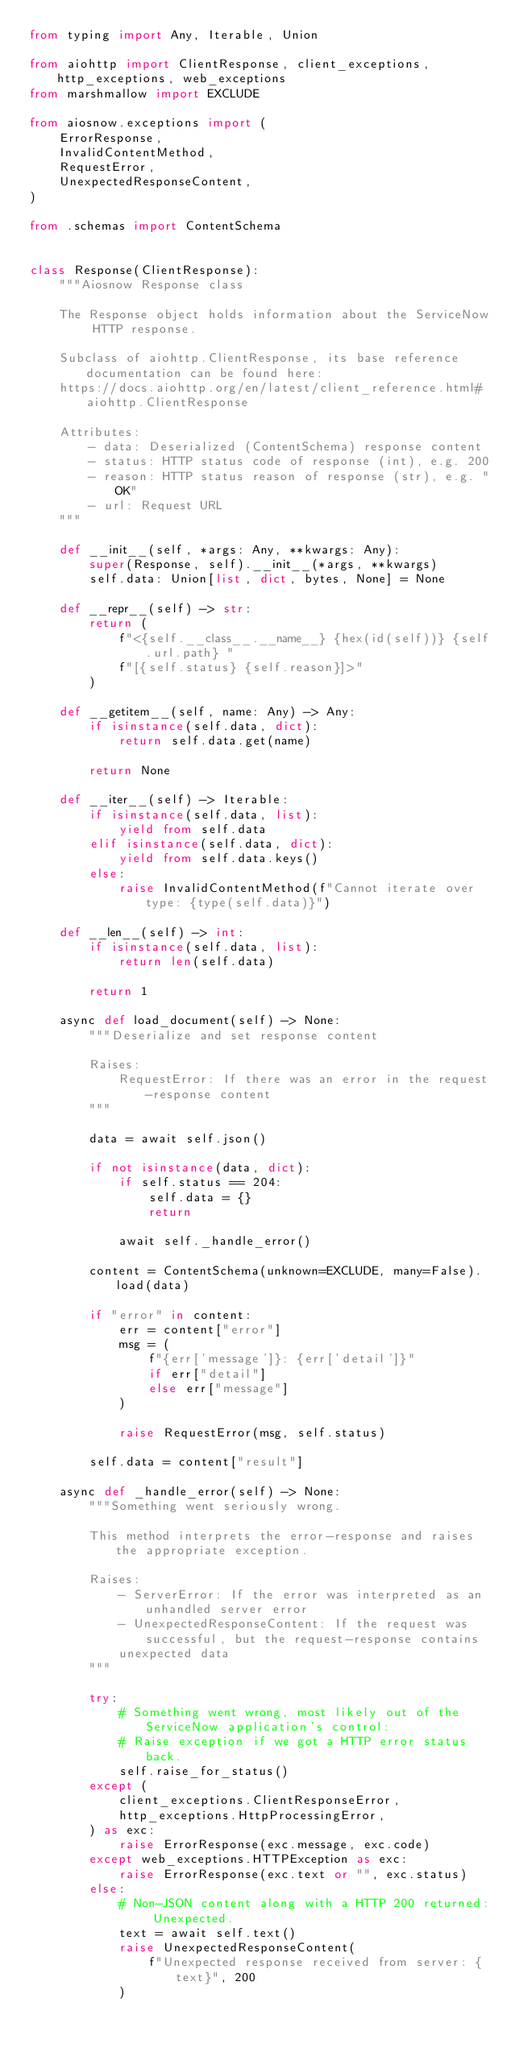<code> <loc_0><loc_0><loc_500><loc_500><_Python_>from typing import Any, Iterable, Union

from aiohttp import ClientResponse, client_exceptions, http_exceptions, web_exceptions
from marshmallow import EXCLUDE

from aiosnow.exceptions import (
    ErrorResponse,
    InvalidContentMethod,
    RequestError,
    UnexpectedResponseContent,
)

from .schemas import ContentSchema


class Response(ClientResponse):
    """Aiosnow Response class

    The Response object holds information about the ServiceNow HTTP response.

    Subclass of aiohttp.ClientResponse, its base reference documentation can be found here:
    https://docs.aiohttp.org/en/latest/client_reference.html#aiohttp.ClientResponse

    Attributes:
        - data: Deserialized (ContentSchema) response content
        - status: HTTP status code of response (int), e.g. 200
        - reason: HTTP status reason of response (str), e.g. "OK"
        - url: Request URL
    """

    def __init__(self, *args: Any, **kwargs: Any):
        super(Response, self).__init__(*args, **kwargs)
        self.data: Union[list, dict, bytes, None] = None

    def __repr__(self) -> str:
        return (
            f"<{self.__class__.__name__} {hex(id(self))} {self.url.path} "
            f"[{self.status} {self.reason}]>"
        )

    def __getitem__(self, name: Any) -> Any:
        if isinstance(self.data, dict):
            return self.data.get(name)

        return None

    def __iter__(self) -> Iterable:
        if isinstance(self.data, list):
            yield from self.data
        elif isinstance(self.data, dict):
            yield from self.data.keys()
        else:
            raise InvalidContentMethod(f"Cannot iterate over type: {type(self.data)}")

    def __len__(self) -> int:
        if isinstance(self.data, list):
            return len(self.data)

        return 1

    async def load_document(self) -> None:
        """Deserialize and set response content

        Raises:
            RequestError: If there was an error in the request-response content
        """

        data = await self.json()

        if not isinstance(data, dict):
            if self.status == 204:
                self.data = {}
                return

            await self._handle_error()

        content = ContentSchema(unknown=EXCLUDE, many=False).load(data)

        if "error" in content:
            err = content["error"]
            msg = (
                f"{err['message']}: {err['detail']}"
                if err["detail"]
                else err["message"]
            )

            raise RequestError(msg, self.status)

        self.data = content["result"]

    async def _handle_error(self) -> None:
        """Something went seriously wrong.

        This method interprets the error-response and raises the appropriate exception.

        Raises:
            - ServerError: If the error was interpreted as an unhandled server error
            - UnexpectedResponseContent: If the request was successful, but the request-response contains
            unexpected data
        """

        try:
            # Something went wrong, most likely out of the ServiceNow application's control:
            # Raise exception if we got a HTTP error status back.
            self.raise_for_status()
        except (
            client_exceptions.ClientResponseError,
            http_exceptions.HttpProcessingError,
        ) as exc:
            raise ErrorResponse(exc.message, exc.code)
        except web_exceptions.HTTPException as exc:
            raise ErrorResponse(exc.text or "", exc.status)
        else:
            # Non-JSON content along with a HTTP 200 returned: Unexpected.
            text = await self.text()
            raise UnexpectedResponseContent(
                f"Unexpected response received from server: {text}", 200
            )
</code> 